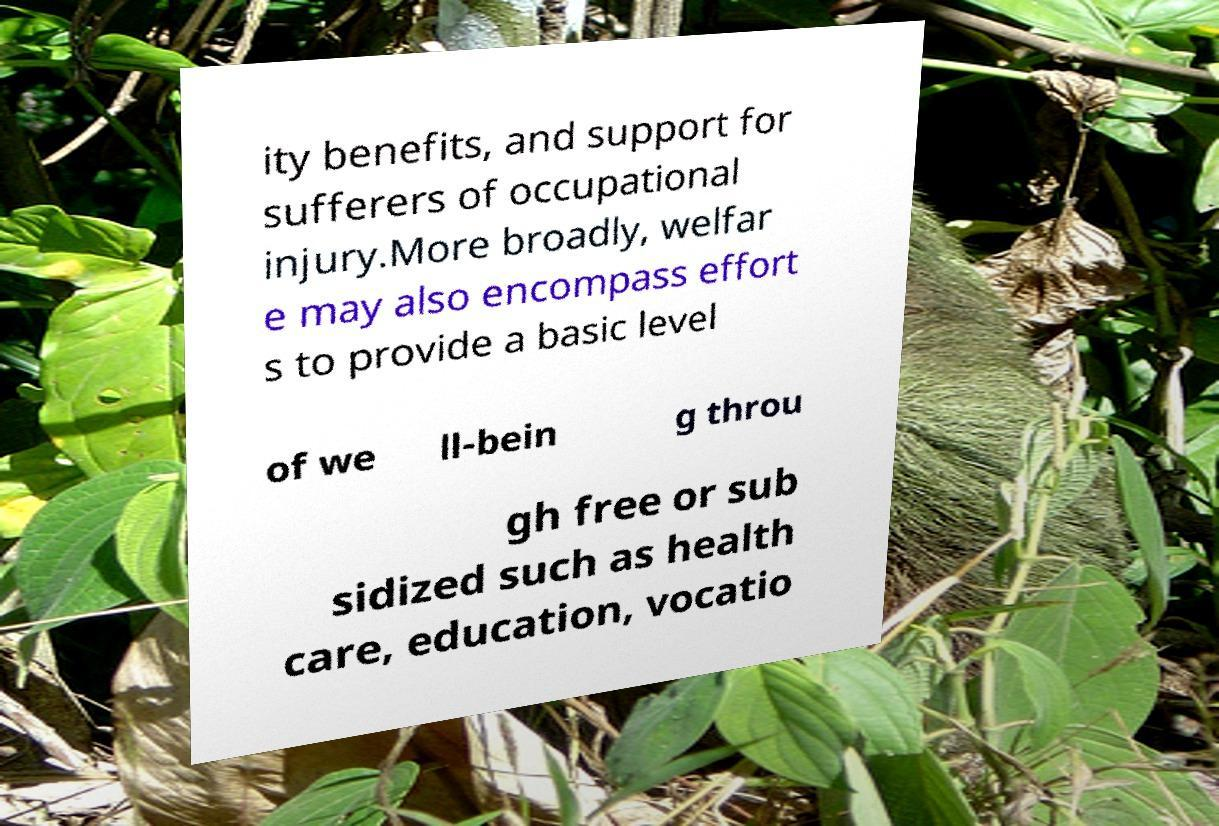Could you assist in decoding the text presented in this image and type it out clearly? ity benefits, and support for sufferers of occupational injury.More broadly, welfar e may also encompass effort s to provide a basic level of we ll-bein g throu gh free or sub sidized such as health care, education, vocatio 